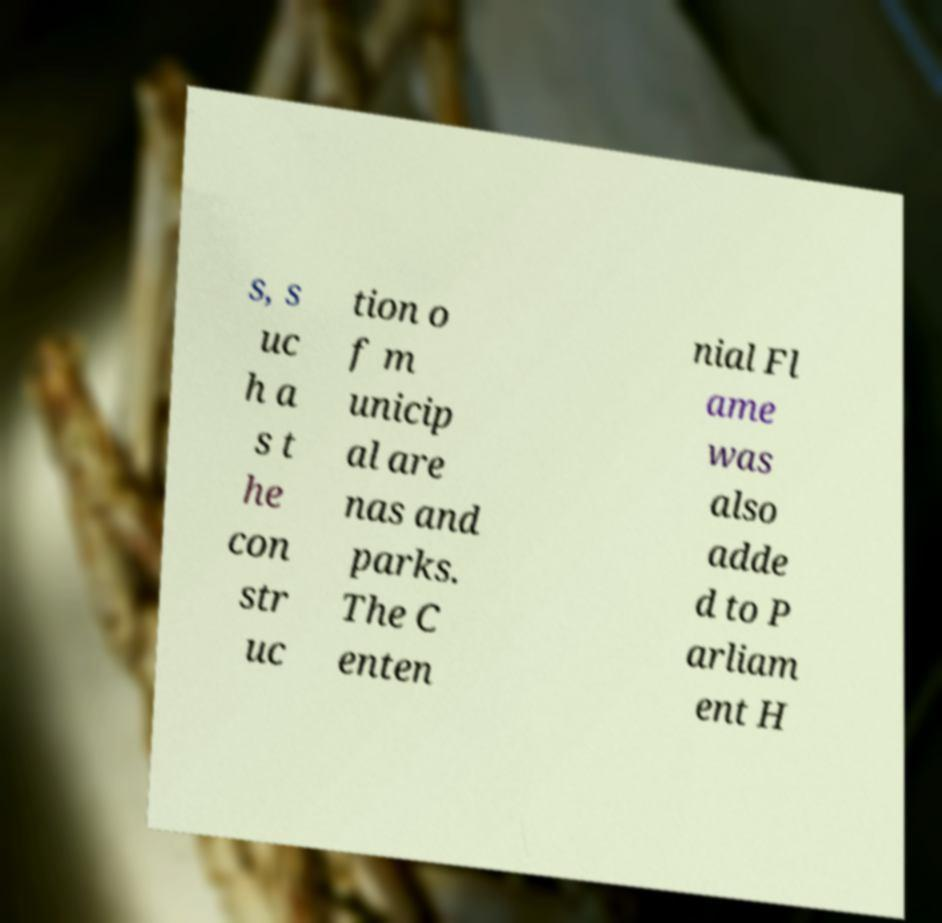Can you accurately transcribe the text from the provided image for me? s, s uc h a s t he con str uc tion o f m unicip al are nas and parks. The C enten nial Fl ame was also adde d to P arliam ent H 